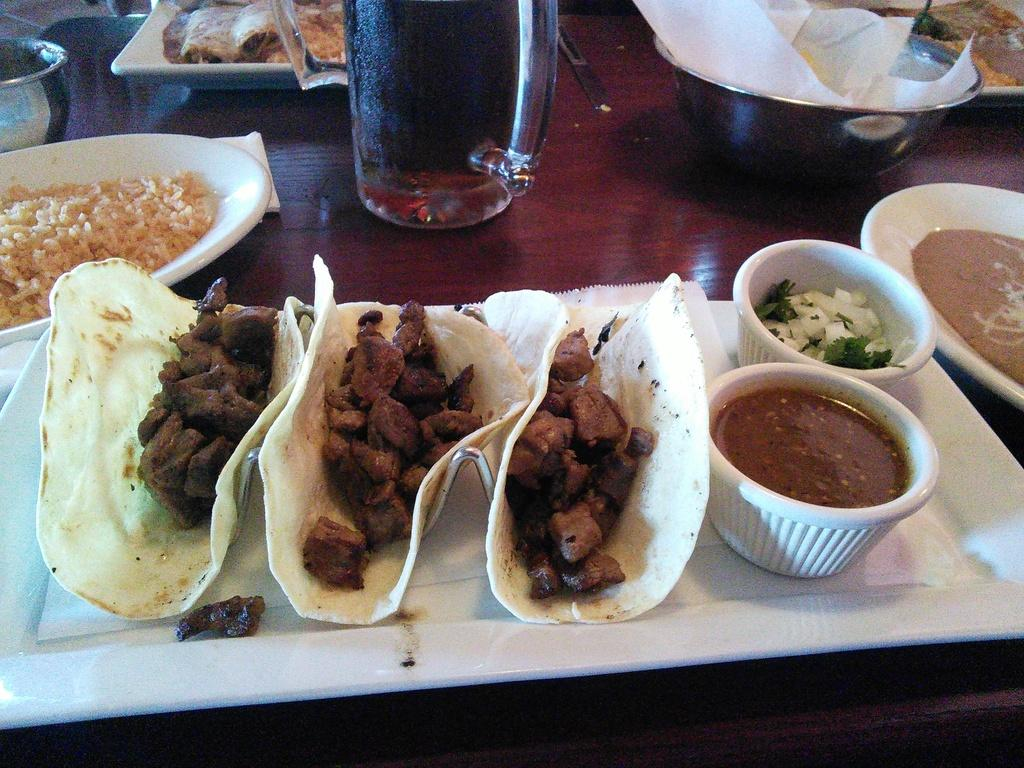What type of food can be seen in the image? There is food in the image, including a salad. What accompanies the food on the plate? There is sauce on the plate with the food and salad. What is the container for the sauce? The sauce is placed on a plate. What is the beverage container in the image? There is a glass in the image. Where are the tissue papers stored in the image? The tissue papers are in a bowl in the image. On what surface are all these items placed? All these items are on a table. How many brothers are sitting at the table in the image? There is no mention of brothers or anyone sitting at the table in the image. What type of friction can be observed between the food and the plate in the image? There is no indication of friction between the food and the plate in the image; they are simply placed together on the plate. Is there a tiger visible in the image? No, there is no tiger present in the image. 